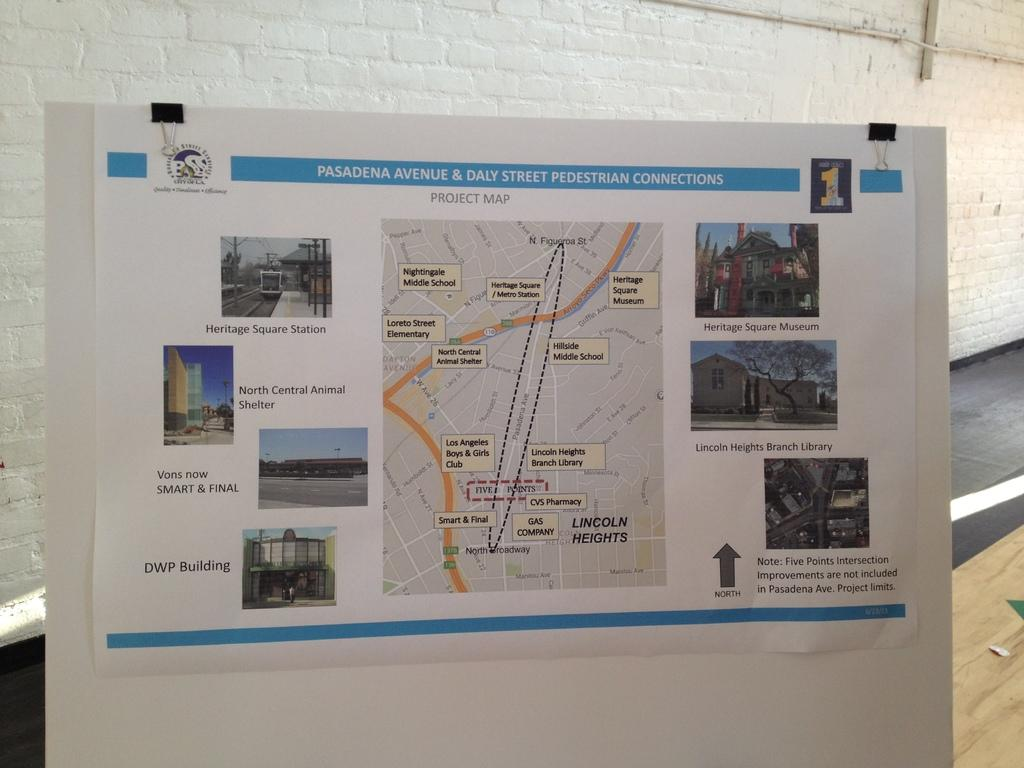<image>
Render a clear and concise summary of the photo. A map on a poster titled Pasadena Avenue & Daly Street pedestrian connections. 